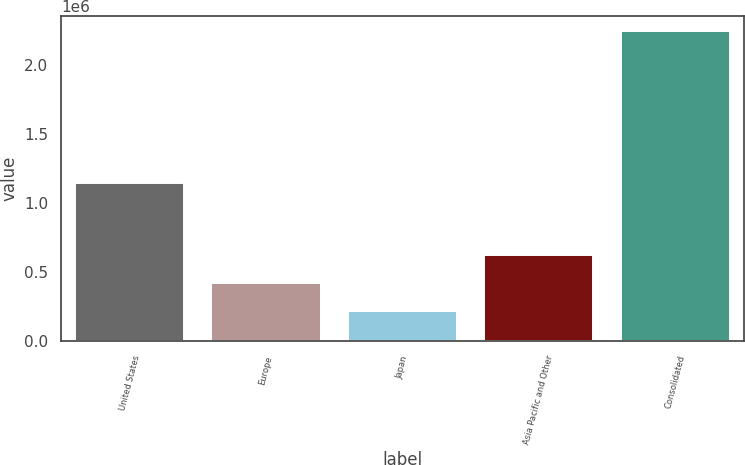Convert chart to OTSL. <chart><loc_0><loc_0><loc_500><loc_500><bar_chart><fcel>United States<fcel>Europe<fcel>Japan<fcel>Asia Pacific and Other<fcel>Consolidated<nl><fcel>1.14382e+06<fcel>421136<fcel>218794<fcel>623477<fcel>2.24221e+06<nl></chart> 